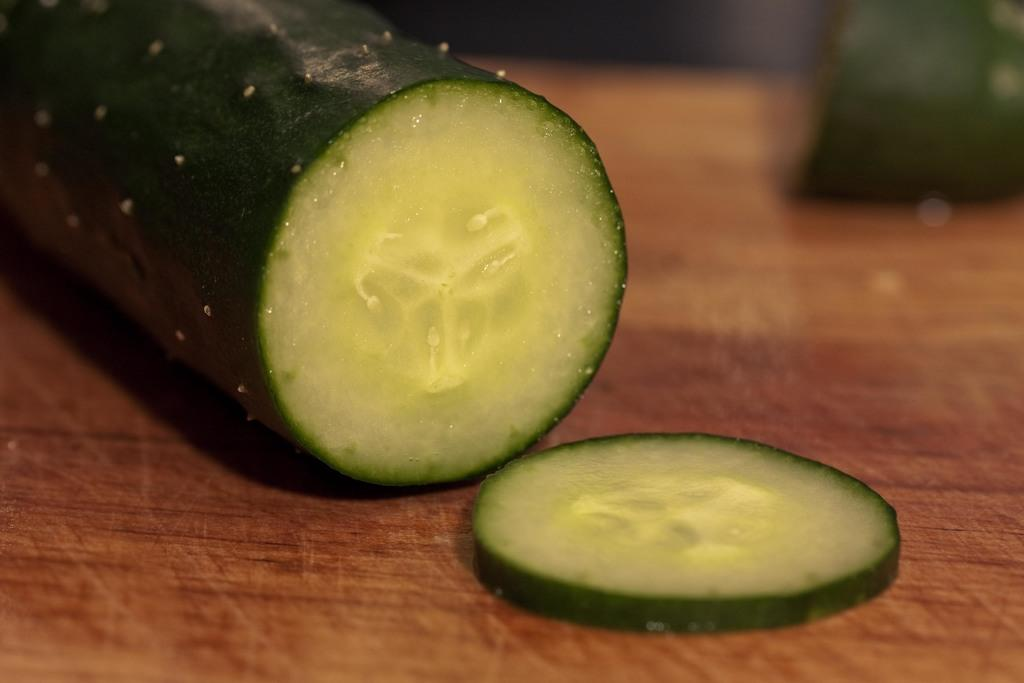What is the main subject of the image? The main subject of the image is a cucumber slice. Can you describe the setting of the image? The image shows a cucumber slice, and in the background, there are more cucumbers on a table. How many passengers are in the tent in the image? There is no tent or passengers present in the image. What type of pump is used to inflate the cucumber in the image? There is no pump or inflation process involved with the cucumber in the image. 